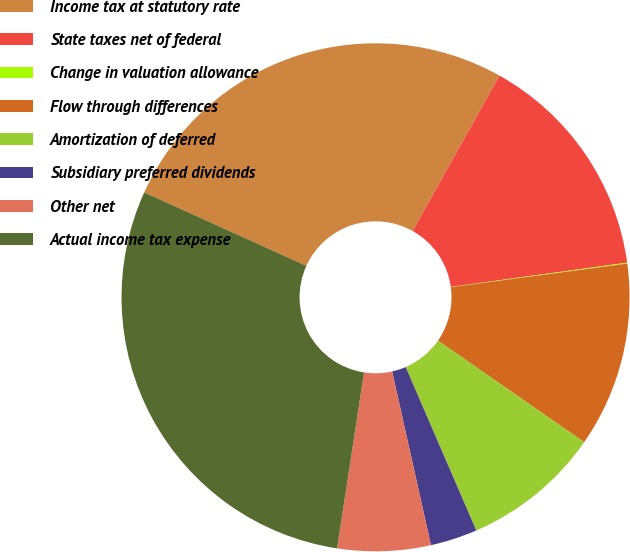Convert chart to OTSL. <chart><loc_0><loc_0><loc_500><loc_500><pie_chart><fcel>Income tax at statutory rate<fcel>State taxes net of federal<fcel>Change in valuation allowance<fcel>Flow through differences<fcel>Amortization of deferred<fcel>Subsidiary preferred dividends<fcel>Other net<fcel>Actual income tax expense<nl><fcel>26.34%<fcel>14.71%<fcel>0.06%<fcel>11.78%<fcel>8.85%<fcel>2.99%<fcel>5.92%<fcel>29.36%<nl></chart> 